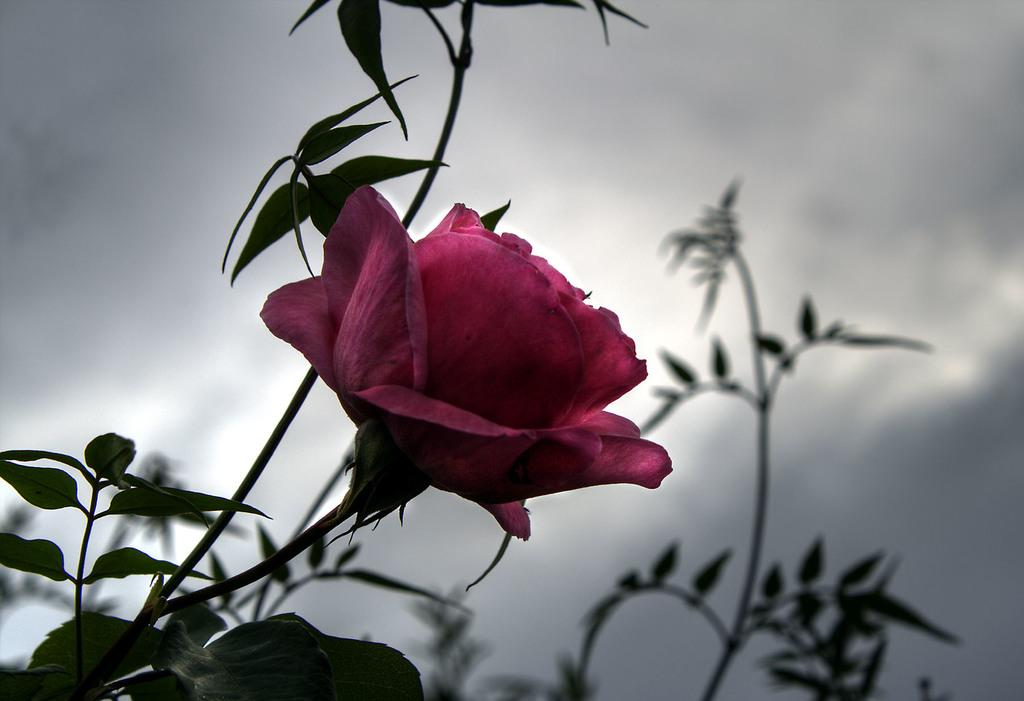What type of plant can be seen in the image? There is a flower in the image. What else is visible on the plant besides the flower? There are leaves in the image. What can be seen in the background of the image? There are plants and clouds visible in the background of the image. What part of the natural environment is visible in the image? The sky is visible in the background of the image. What type of whistle is being used by the governor in the image? There is no whistle or governor present in the image; it features a flower, leaves, plants, clouds, and the sky. 